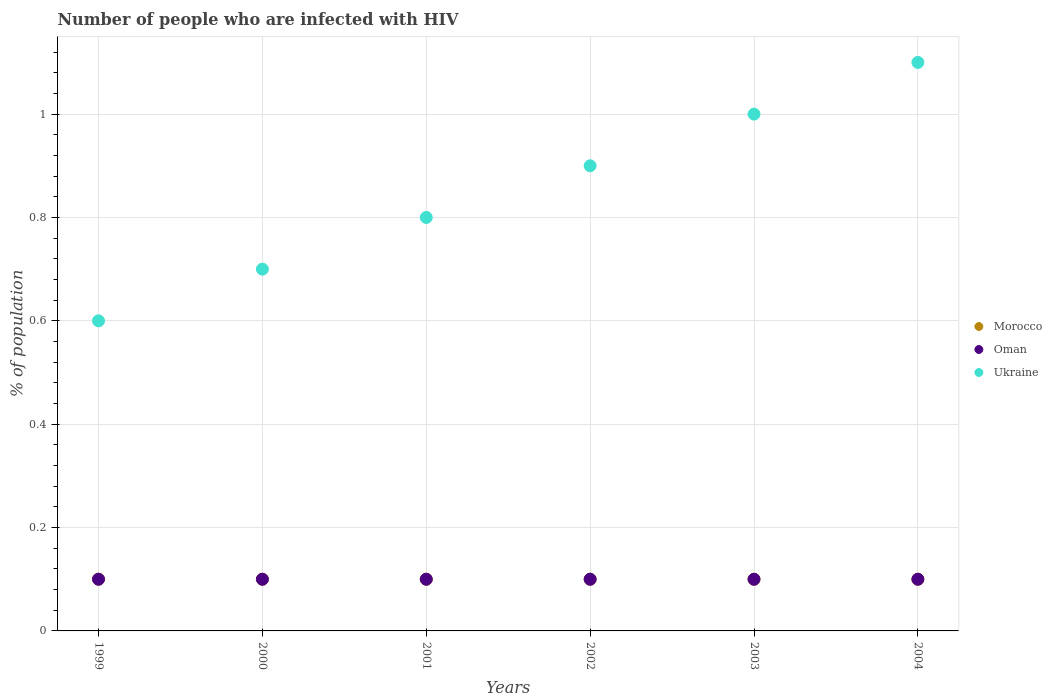How many different coloured dotlines are there?
Keep it short and to the point. 3. What is the percentage of HIV infected population in in Ukraine in 1999?
Provide a succinct answer. 0.6. What is the total percentage of HIV infected population in in Morocco in the graph?
Give a very brief answer. 0.6. What is the difference between the percentage of HIV infected population in in Ukraine in 2000 and that in 2002?
Provide a succinct answer. -0.2. What is the difference between the percentage of HIV infected population in in Morocco in 2003 and the percentage of HIV infected population in in Oman in 2001?
Provide a succinct answer. 0. What is the average percentage of HIV infected population in in Oman per year?
Your answer should be very brief. 0.1. In the year 2001, what is the difference between the percentage of HIV infected population in in Ukraine and percentage of HIV infected population in in Oman?
Your answer should be compact. 0.7. In how many years, is the percentage of HIV infected population in in Ukraine greater than 0.2 %?
Make the answer very short. 6. What is the difference between the highest and the second highest percentage of HIV infected population in in Ukraine?
Your answer should be compact. 0.1. What is the difference between the highest and the lowest percentage of HIV infected population in in Ukraine?
Keep it short and to the point. 0.5. In how many years, is the percentage of HIV infected population in in Morocco greater than the average percentage of HIV infected population in in Morocco taken over all years?
Your response must be concise. 6. Is the sum of the percentage of HIV infected population in in Morocco in 2002 and 2004 greater than the maximum percentage of HIV infected population in in Ukraine across all years?
Provide a short and direct response. No. Does the percentage of HIV infected population in in Ukraine monotonically increase over the years?
Provide a short and direct response. Yes. How many dotlines are there?
Offer a terse response. 3. How many years are there in the graph?
Make the answer very short. 6. Does the graph contain any zero values?
Give a very brief answer. No. What is the title of the graph?
Offer a terse response. Number of people who are infected with HIV. What is the label or title of the Y-axis?
Provide a short and direct response. % of population. What is the % of population of Ukraine in 1999?
Provide a succinct answer. 0.6. What is the % of population in Oman in 2000?
Give a very brief answer. 0.1. What is the % of population in Morocco in 2001?
Your response must be concise. 0.1. What is the % of population in Oman in 2001?
Your answer should be compact. 0.1. What is the % of population in Morocco in 2002?
Offer a terse response. 0.1. What is the % of population in Morocco in 2003?
Give a very brief answer. 0.1. Across all years, what is the maximum % of population of Morocco?
Offer a very short reply. 0.1. Across all years, what is the minimum % of population of Morocco?
Your answer should be compact. 0.1. Across all years, what is the minimum % of population in Oman?
Provide a succinct answer. 0.1. What is the total % of population of Ukraine in the graph?
Give a very brief answer. 5.1. What is the difference between the % of population of Morocco in 1999 and that in 2000?
Keep it short and to the point. 0. What is the difference between the % of population in Oman in 1999 and that in 2000?
Your response must be concise. 0. What is the difference between the % of population of Morocco in 1999 and that in 2001?
Offer a terse response. 0. What is the difference between the % of population of Oman in 1999 and that in 2001?
Your answer should be compact. 0. What is the difference between the % of population of Ukraine in 1999 and that in 2001?
Make the answer very short. -0.2. What is the difference between the % of population of Oman in 1999 and that in 2002?
Ensure brevity in your answer.  0. What is the difference between the % of population in Ukraine in 1999 and that in 2002?
Make the answer very short. -0.3. What is the difference between the % of population of Morocco in 1999 and that in 2003?
Provide a short and direct response. 0. What is the difference between the % of population of Ukraine in 1999 and that in 2003?
Your response must be concise. -0.4. What is the difference between the % of population of Ukraine in 1999 and that in 2004?
Make the answer very short. -0.5. What is the difference between the % of population of Morocco in 2000 and that in 2001?
Your answer should be compact. 0. What is the difference between the % of population in Morocco in 2000 and that in 2002?
Keep it short and to the point. 0. What is the difference between the % of population in Morocco in 2000 and that in 2003?
Your answer should be compact. 0. What is the difference between the % of population of Morocco in 2000 and that in 2004?
Offer a terse response. 0. What is the difference between the % of population of Ukraine in 2000 and that in 2004?
Offer a very short reply. -0.4. What is the difference between the % of population of Morocco in 2001 and that in 2002?
Provide a succinct answer. 0. What is the difference between the % of population of Ukraine in 2001 and that in 2004?
Your answer should be very brief. -0.3. What is the difference between the % of population of Ukraine in 2002 and that in 2003?
Offer a very short reply. -0.1. What is the difference between the % of population of Oman in 2003 and that in 2004?
Ensure brevity in your answer.  0. What is the difference between the % of population of Ukraine in 2003 and that in 2004?
Your answer should be very brief. -0.1. What is the difference between the % of population in Morocco in 1999 and the % of population in Ukraine in 2000?
Provide a succinct answer. -0.6. What is the difference between the % of population in Morocco in 1999 and the % of population in Ukraine in 2001?
Make the answer very short. -0.7. What is the difference between the % of population in Morocco in 1999 and the % of population in Ukraine in 2002?
Offer a very short reply. -0.8. What is the difference between the % of population in Morocco in 1999 and the % of population in Oman in 2003?
Provide a short and direct response. 0. What is the difference between the % of population of Morocco in 1999 and the % of population of Ukraine in 2003?
Ensure brevity in your answer.  -0.9. What is the difference between the % of population of Oman in 1999 and the % of population of Ukraine in 2003?
Provide a succinct answer. -0.9. What is the difference between the % of population of Morocco in 1999 and the % of population of Ukraine in 2004?
Make the answer very short. -1. What is the difference between the % of population in Morocco in 2000 and the % of population in Oman in 2001?
Give a very brief answer. 0. What is the difference between the % of population of Morocco in 2000 and the % of population of Ukraine in 2002?
Your response must be concise. -0.8. What is the difference between the % of population in Morocco in 2000 and the % of population in Oman in 2003?
Your answer should be compact. 0. What is the difference between the % of population in Oman in 2000 and the % of population in Ukraine in 2003?
Your answer should be very brief. -0.9. What is the difference between the % of population of Oman in 2000 and the % of population of Ukraine in 2004?
Your response must be concise. -1. What is the difference between the % of population of Morocco in 2001 and the % of population of Ukraine in 2002?
Make the answer very short. -0.8. What is the difference between the % of population of Oman in 2001 and the % of population of Ukraine in 2002?
Provide a short and direct response. -0.8. What is the difference between the % of population in Morocco in 2001 and the % of population in Ukraine in 2003?
Give a very brief answer. -0.9. What is the difference between the % of population in Morocco in 2001 and the % of population in Oman in 2004?
Give a very brief answer. 0. What is the difference between the % of population of Morocco in 2001 and the % of population of Ukraine in 2004?
Your answer should be compact. -1. What is the difference between the % of population of Oman in 2001 and the % of population of Ukraine in 2004?
Your response must be concise. -1. What is the difference between the % of population of Morocco in 2002 and the % of population of Oman in 2003?
Give a very brief answer. 0. What is the difference between the % of population in Morocco in 2002 and the % of population in Ukraine in 2003?
Give a very brief answer. -0.9. What is the difference between the % of population in Morocco in 2002 and the % of population in Ukraine in 2004?
Keep it short and to the point. -1. What is the difference between the % of population in Oman in 2002 and the % of population in Ukraine in 2004?
Keep it short and to the point. -1. What is the difference between the % of population in Morocco in 2003 and the % of population in Ukraine in 2004?
Provide a short and direct response. -1. What is the average % of population in Morocco per year?
Give a very brief answer. 0.1. In the year 1999, what is the difference between the % of population in Morocco and % of population in Oman?
Keep it short and to the point. 0. In the year 1999, what is the difference between the % of population of Morocco and % of population of Ukraine?
Offer a very short reply. -0.5. In the year 1999, what is the difference between the % of population of Oman and % of population of Ukraine?
Your answer should be compact. -0.5. In the year 2000, what is the difference between the % of population of Morocco and % of population of Oman?
Provide a short and direct response. 0. In the year 2000, what is the difference between the % of population in Morocco and % of population in Ukraine?
Give a very brief answer. -0.6. In the year 2000, what is the difference between the % of population in Oman and % of population in Ukraine?
Provide a succinct answer. -0.6. In the year 2001, what is the difference between the % of population of Morocco and % of population of Ukraine?
Your answer should be compact. -0.7. In the year 2001, what is the difference between the % of population in Oman and % of population in Ukraine?
Give a very brief answer. -0.7. In the year 2002, what is the difference between the % of population in Morocco and % of population in Oman?
Provide a short and direct response. 0. In the year 2003, what is the difference between the % of population in Morocco and % of population in Oman?
Make the answer very short. 0. In the year 2003, what is the difference between the % of population of Morocco and % of population of Ukraine?
Ensure brevity in your answer.  -0.9. In the year 2003, what is the difference between the % of population in Oman and % of population in Ukraine?
Your answer should be compact. -0.9. In the year 2004, what is the difference between the % of population of Morocco and % of population of Ukraine?
Your answer should be compact. -1. In the year 2004, what is the difference between the % of population in Oman and % of population in Ukraine?
Offer a terse response. -1. What is the ratio of the % of population in Morocco in 1999 to that in 2001?
Your answer should be very brief. 1. What is the ratio of the % of population of Oman in 1999 to that in 2001?
Your answer should be compact. 1. What is the ratio of the % of population of Ukraine in 1999 to that in 2001?
Your answer should be very brief. 0.75. What is the ratio of the % of population of Morocco in 1999 to that in 2002?
Provide a succinct answer. 1. What is the ratio of the % of population of Morocco in 1999 to that in 2003?
Provide a succinct answer. 1. What is the ratio of the % of population in Ukraine in 1999 to that in 2003?
Your response must be concise. 0.6. What is the ratio of the % of population in Morocco in 1999 to that in 2004?
Keep it short and to the point. 1. What is the ratio of the % of population of Oman in 1999 to that in 2004?
Offer a terse response. 1. What is the ratio of the % of population of Ukraine in 1999 to that in 2004?
Provide a succinct answer. 0.55. What is the ratio of the % of population of Morocco in 2000 to that in 2001?
Make the answer very short. 1. What is the ratio of the % of population of Ukraine in 2000 to that in 2001?
Your answer should be compact. 0.88. What is the ratio of the % of population in Ukraine in 2000 to that in 2002?
Ensure brevity in your answer.  0.78. What is the ratio of the % of population of Oman in 2000 to that in 2003?
Make the answer very short. 1. What is the ratio of the % of population in Ukraine in 2000 to that in 2003?
Provide a short and direct response. 0.7. What is the ratio of the % of population of Ukraine in 2000 to that in 2004?
Give a very brief answer. 0.64. What is the ratio of the % of population of Morocco in 2001 to that in 2002?
Offer a terse response. 1. What is the ratio of the % of population of Oman in 2001 to that in 2002?
Offer a terse response. 1. What is the ratio of the % of population in Ukraine in 2001 to that in 2002?
Provide a succinct answer. 0.89. What is the ratio of the % of population in Oman in 2001 to that in 2003?
Your response must be concise. 1. What is the ratio of the % of population of Oman in 2001 to that in 2004?
Keep it short and to the point. 1. What is the ratio of the % of population of Ukraine in 2001 to that in 2004?
Your answer should be very brief. 0.73. What is the ratio of the % of population of Morocco in 2002 to that in 2003?
Make the answer very short. 1. What is the ratio of the % of population of Ukraine in 2002 to that in 2003?
Your answer should be very brief. 0.9. What is the ratio of the % of population in Ukraine in 2002 to that in 2004?
Your response must be concise. 0.82. What is the ratio of the % of population in Morocco in 2003 to that in 2004?
Give a very brief answer. 1. What is the ratio of the % of population in Oman in 2003 to that in 2004?
Your response must be concise. 1. What is the difference between the highest and the second highest % of population of Morocco?
Offer a terse response. 0. What is the difference between the highest and the lowest % of population of Oman?
Provide a short and direct response. 0. 